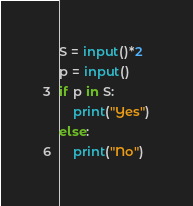<code> <loc_0><loc_0><loc_500><loc_500><_Python_>S = input()*2
p = input()
if p in S:
    print("Yes")
else:
    print("No")
</code> 